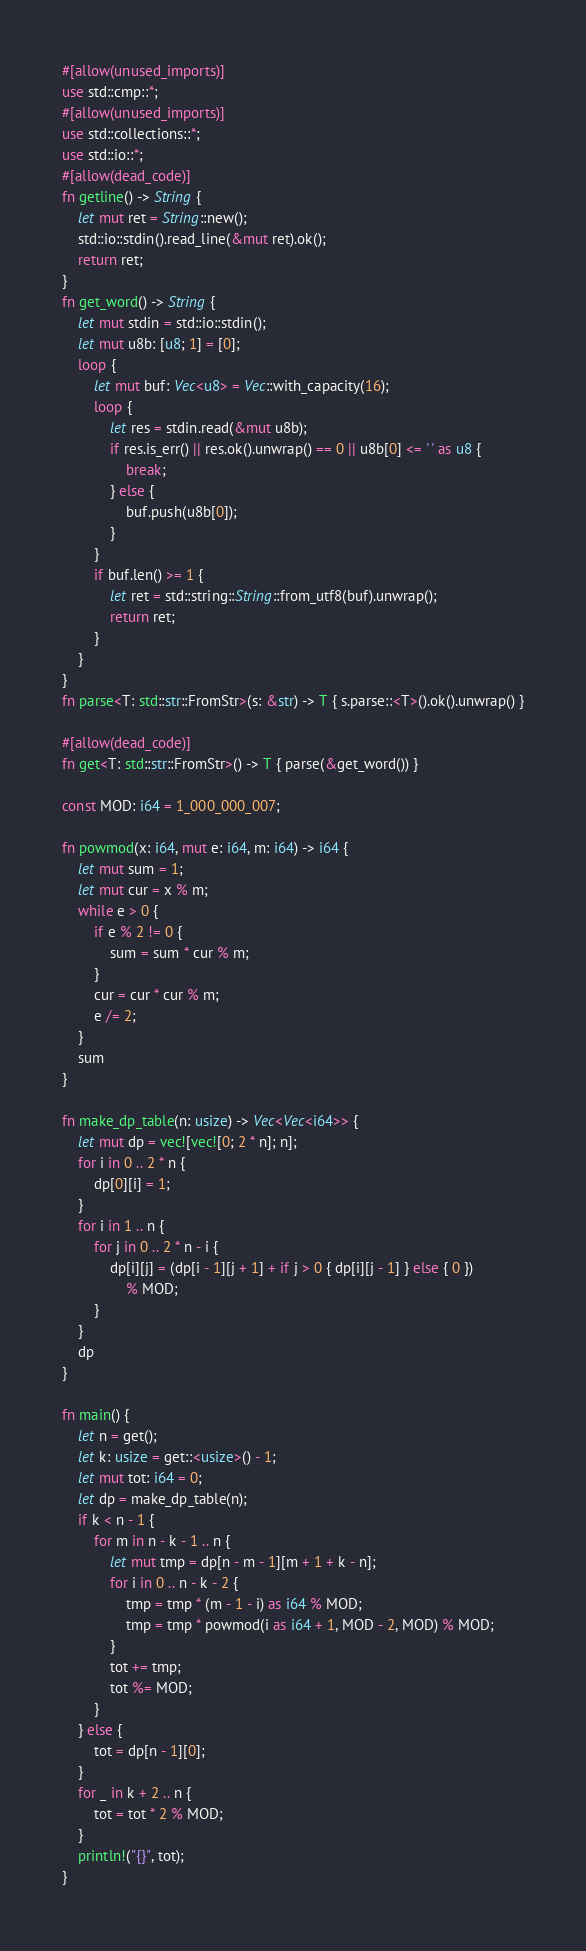<code> <loc_0><loc_0><loc_500><loc_500><_Rust_>#[allow(unused_imports)]
use std::cmp::*;
#[allow(unused_imports)]
use std::collections::*;
use std::io::*;
#[allow(dead_code)]
fn getline() -> String {
    let mut ret = String::new();
    std::io::stdin().read_line(&mut ret).ok();
    return ret;
}
fn get_word() -> String {
    let mut stdin = std::io::stdin();
    let mut u8b: [u8; 1] = [0];
    loop {
        let mut buf: Vec<u8> = Vec::with_capacity(16);
        loop {
            let res = stdin.read(&mut u8b);
            if res.is_err() || res.ok().unwrap() == 0 || u8b[0] <= ' ' as u8 {
                break;
            } else {
                buf.push(u8b[0]);
            }
        }
        if buf.len() >= 1 {
            let ret = std::string::String::from_utf8(buf).unwrap();
            return ret;
        }
    }
}
fn parse<T: std::str::FromStr>(s: &str) -> T { s.parse::<T>().ok().unwrap() }

#[allow(dead_code)]
fn get<T: std::str::FromStr>() -> T { parse(&get_word()) }

const MOD: i64 = 1_000_000_007;

fn powmod(x: i64, mut e: i64, m: i64) -> i64 {
    let mut sum = 1;
    let mut cur = x % m;
    while e > 0 {
        if e % 2 != 0 {
            sum = sum * cur % m;
        }
        cur = cur * cur % m;
        e /= 2;
    }
    sum
}

fn make_dp_table(n: usize) -> Vec<Vec<i64>> {
    let mut dp = vec![vec![0; 2 * n]; n];
    for i in 0 .. 2 * n {
        dp[0][i] = 1;
    }
    for i in 1 .. n {
        for j in 0 .. 2 * n - i {
            dp[i][j] = (dp[i - 1][j + 1] + if j > 0 { dp[i][j - 1] } else { 0 })
                % MOD;
        }
    }
    dp
}

fn main() {
    let n = get();
    let k: usize = get::<usize>() - 1;
    let mut tot: i64 = 0;
    let dp = make_dp_table(n);
    if k < n - 1 {
        for m in n - k - 1 .. n {
            let mut tmp = dp[n - m - 1][m + 1 + k - n];
            for i in 0 .. n - k - 2 {
                tmp = tmp * (m - 1 - i) as i64 % MOD;
                tmp = tmp * powmod(i as i64 + 1, MOD - 2, MOD) % MOD; 
            }
            tot += tmp;
            tot %= MOD;
        }
    } else {
        tot = dp[n - 1][0];
    }
    for _ in k + 2 .. n {
        tot = tot * 2 % MOD;
    }
    println!("{}", tot);
}
</code> 